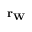Convert formula to latex. <formula><loc_0><loc_0><loc_500><loc_500>r _ { W }</formula> 